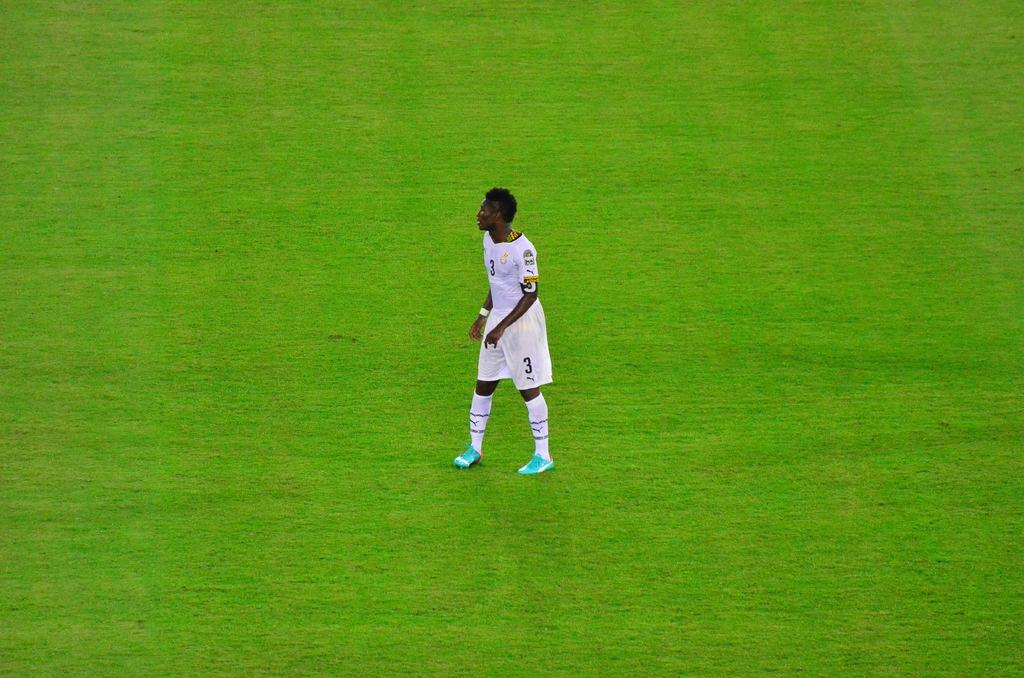Who is present in the image? There is a man in the image. What is the man wearing? The man is wearing a white t-shirt. What is the man's posture in the image? The man is standing. What type of surface is visible at the bottom of the image? There is grass at the bottom of the image. What type of seed is the man holding in the image? There is no seed present in the image; the man is not holding anything. 